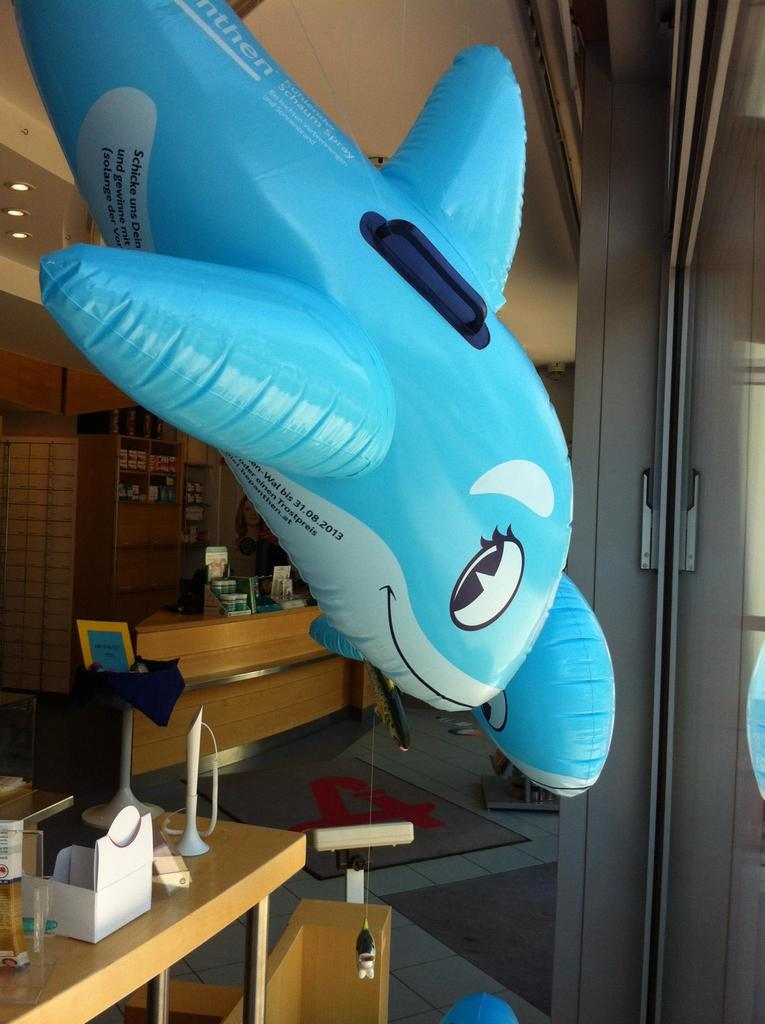<image>
Render a clear and concise summary of the photo. An inflatable blue whale has a number of 31.08.2013 on the side. 